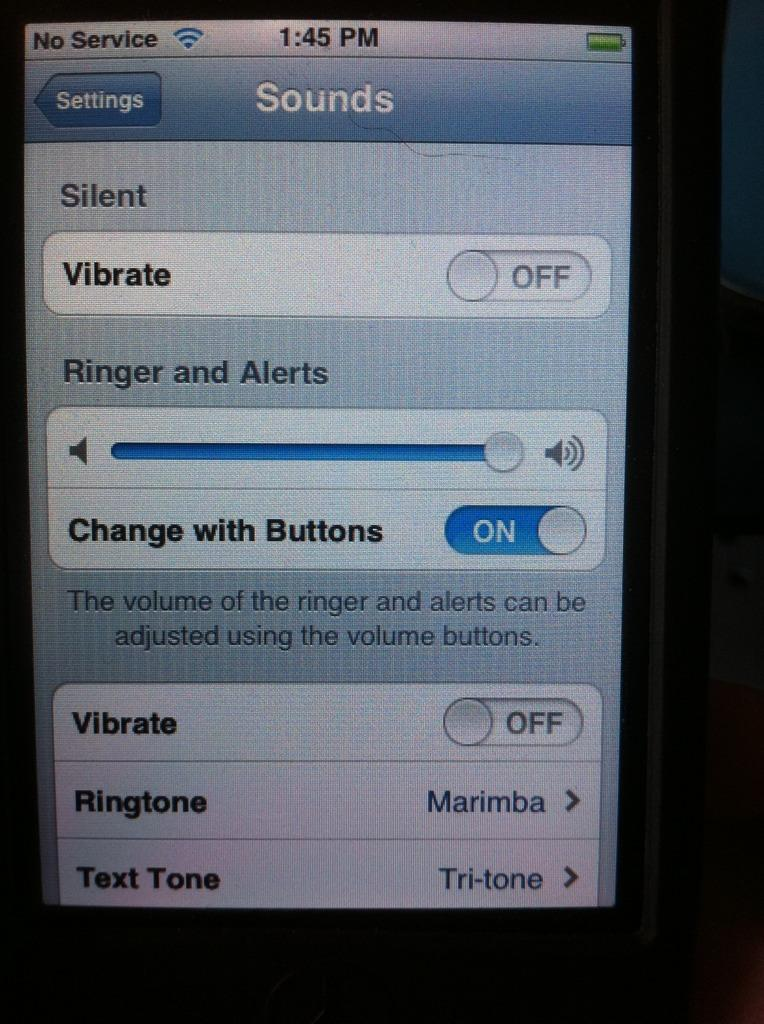<image>
Write a terse but informative summary of the picture. a cell phone screen showing Sounds and Vibrate 